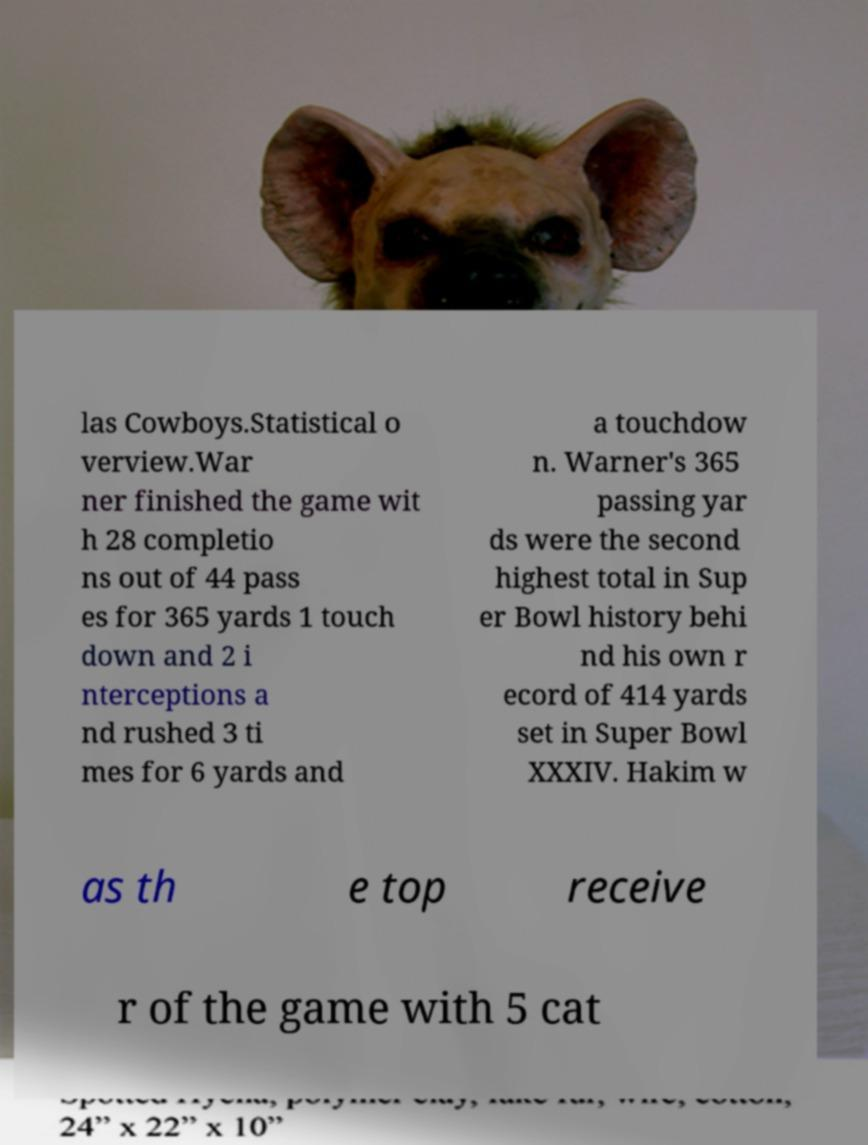There's text embedded in this image that I need extracted. Can you transcribe it verbatim? las Cowboys.Statistical o verview.War ner finished the game wit h 28 completio ns out of 44 pass es for 365 yards 1 touch down and 2 i nterceptions a nd rushed 3 ti mes for 6 yards and a touchdow n. Warner's 365 passing yar ds were the second highest total in Sup er Bowl history behi nd his own r ecord of 414 yards set in Super Bowl XXXIV. Hakim w as th e top receive r of the game with 5 cat 